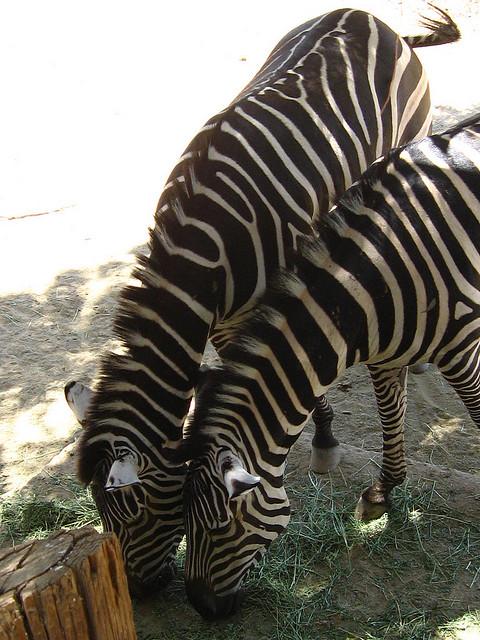Are the zebras sharing space?
Quick response, please. Yes. Are the zebras eating from a tree?
Answer briefly. No. Is there a tree stump next to the zebras?
Concise answer only. Yes. 